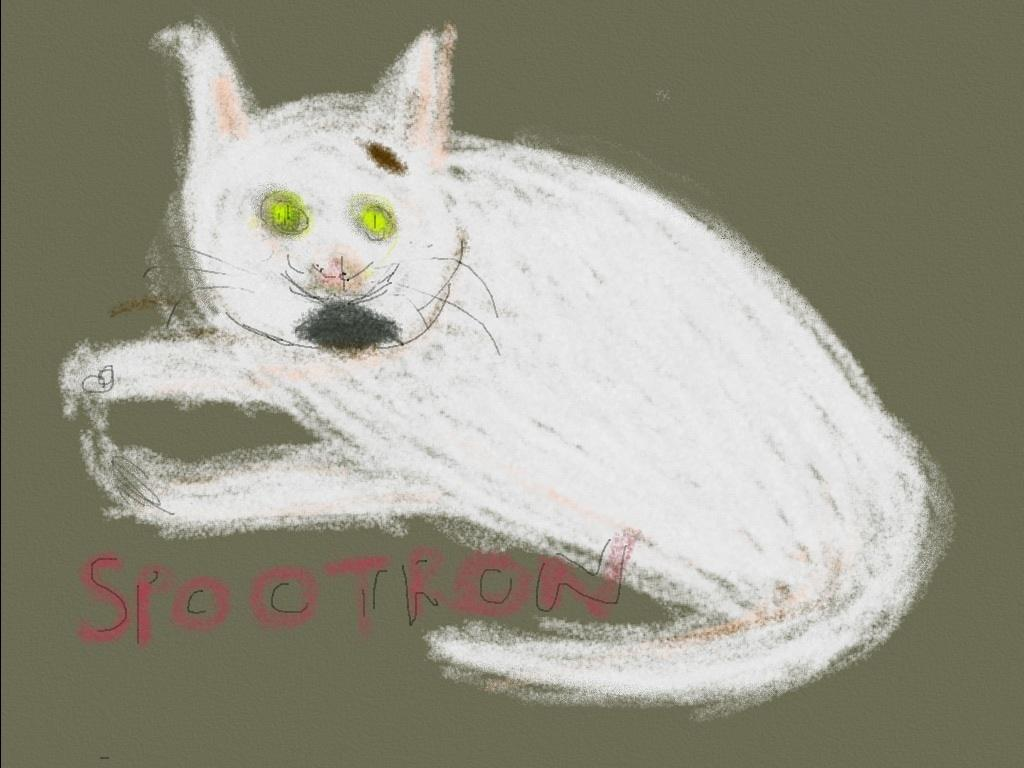What is depicted in the sketch in the image? There is a sketch of a cat in the image. What can be seen on the wall in the image? There is text on the wall in the image. What type of lipstick is the actor wearing in the image? There is no actor or lipstick present in the image; it features a sketch of a cat and text on a wall. How many bikes are visible in the image? There are no bikes present in the image. 